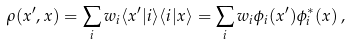<formula> <loc_0><loc_0><loc_500><loc_500>\rho ( x ^ { \prime } , x ) = \sum _ { i } w _ { i } \langle x ^ { \prime } | i \rangle \langle i | x \rangle = \sum _ { i } w _ { i } \phi _ { i } ( x ^ { \prime } ) \phi _ { i } ^ { \ast } ( x ) \, ,</formula> 